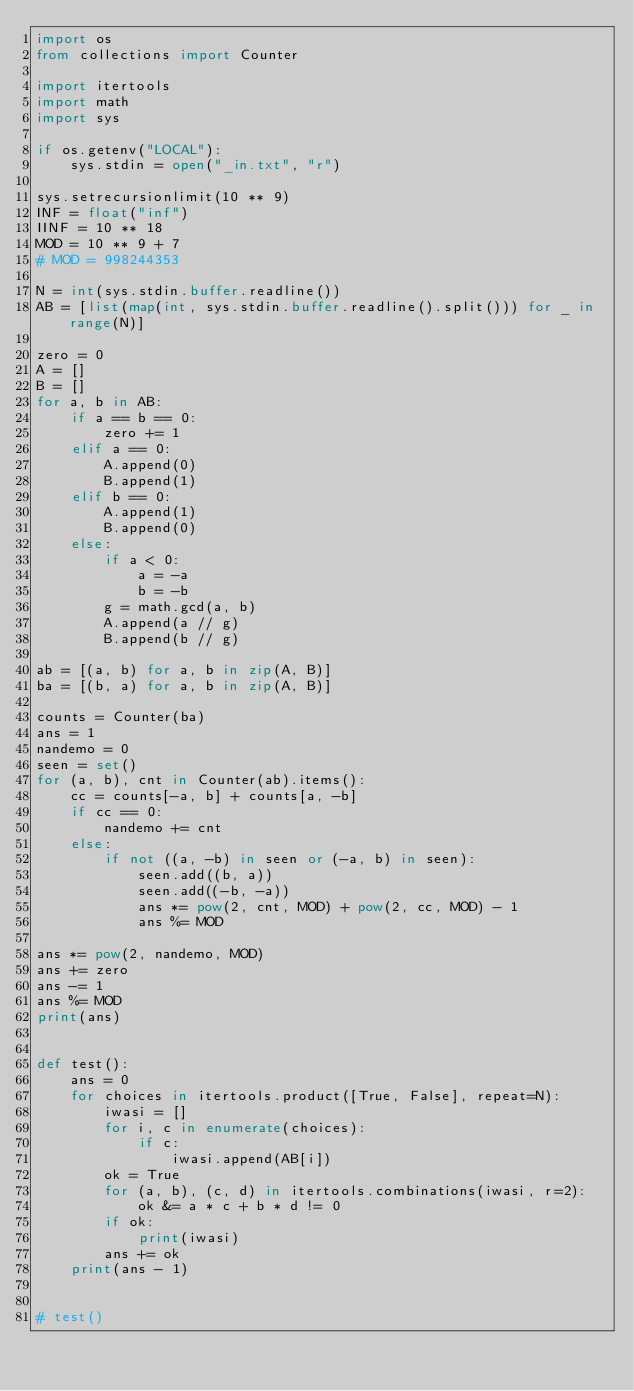<code> <loc_0><loc_0><loc_500><loc_500><_Python_>import os
from collections import Counter

import itertools
import math
import sys

if os.getenv("LOCAL"):
    sys.stdin = open("_in.txt", "r")

sys.setrecursionlimit(10 ** 9)
INF = float("inf")
IINF = 10 ** 18
MOD = 10 ** 9 + 7
# MOD = 998244353

N = int(sys.stdin.buffer.readline())
AB = [list(map(int, sys.stdin.buffer.readline().split())) for _ in range(N)]

zero = 0
A = []
B = []
for a, b in AB:
    if a == b == 0:
        zero += 1
    elif a == 0:
        A.append(0)
        B.append(1)
    elif b == 0:
        A.append(1)
        B.append(0)
    else:
        if a < 0:
            a = -a
            b = -b
        g = math.gcd(a, b)
        A.append(a // g)
        B.append(b // g)

ab = [(a, b) for a, b in zip(A, B)]
ba = [(b, a) for a, b in zip(A, B)]

counts = Counter(ba)
ans = 1
nandemo = 0
seen = set()
for (a, b), cnt in Counter(ab).items():
    cc = counts[-a, b] + counts[a, -b]
    if cc == 0:
        nandemo += cnt
    else:
        if not ((a, -b) in seen or (-a, b) in seen):
            seen.add((b, a))
            seen.add((-b, -a))
            ans *= pow(2, cnt, MOD) + pow(2, cc, MOD) - 1
            ans %= MOD

ans *= pow(2, nandemo, MOD)
ans += zero
ans -= 1
ans %= MOD
print(ans)


def test():
    ans = 0
    for choices in itertools.product([True, False], repeat=N):
        iwasi = []
        for i, c in enumerate(choices):
            if c:
                iwasi.append(AB[i])
        ok = True
        for (a, b), (c, d) in itertools.combinations(iwasi, r=2):
            ok &= a * c + b * d != 0
        if ok:
            print(iwasi)
        ans += ok
    print(ans - 1)


# test()
</code> 